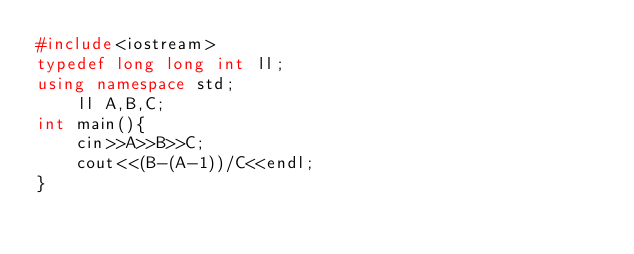<code> <loc_0><loc_0><loc_500><loc_500><_C++_>#include<iostream>
typedef long long int ll;
using namespace std;
    ll A,B,C;
int main(){
    cin>>A>>B>>C;
    cout<<(B-(A-1))/C<<endl;
}</code> 